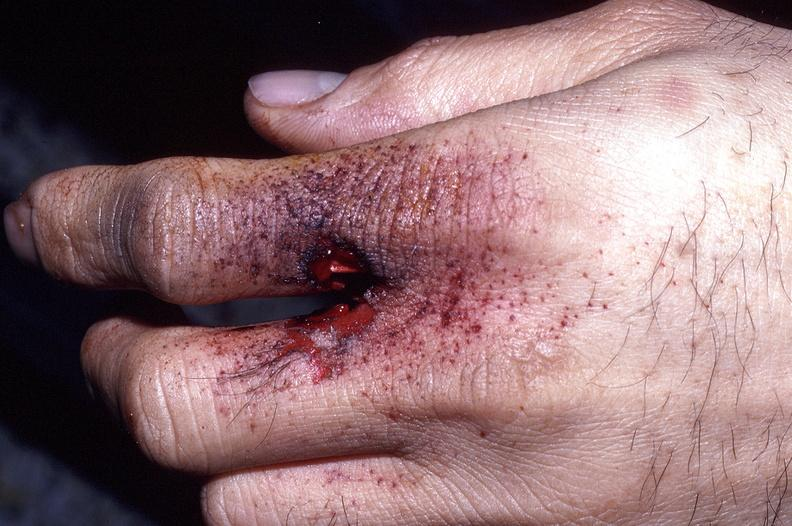what does this image show?
Answer the question using a single word or phrase. Hand 